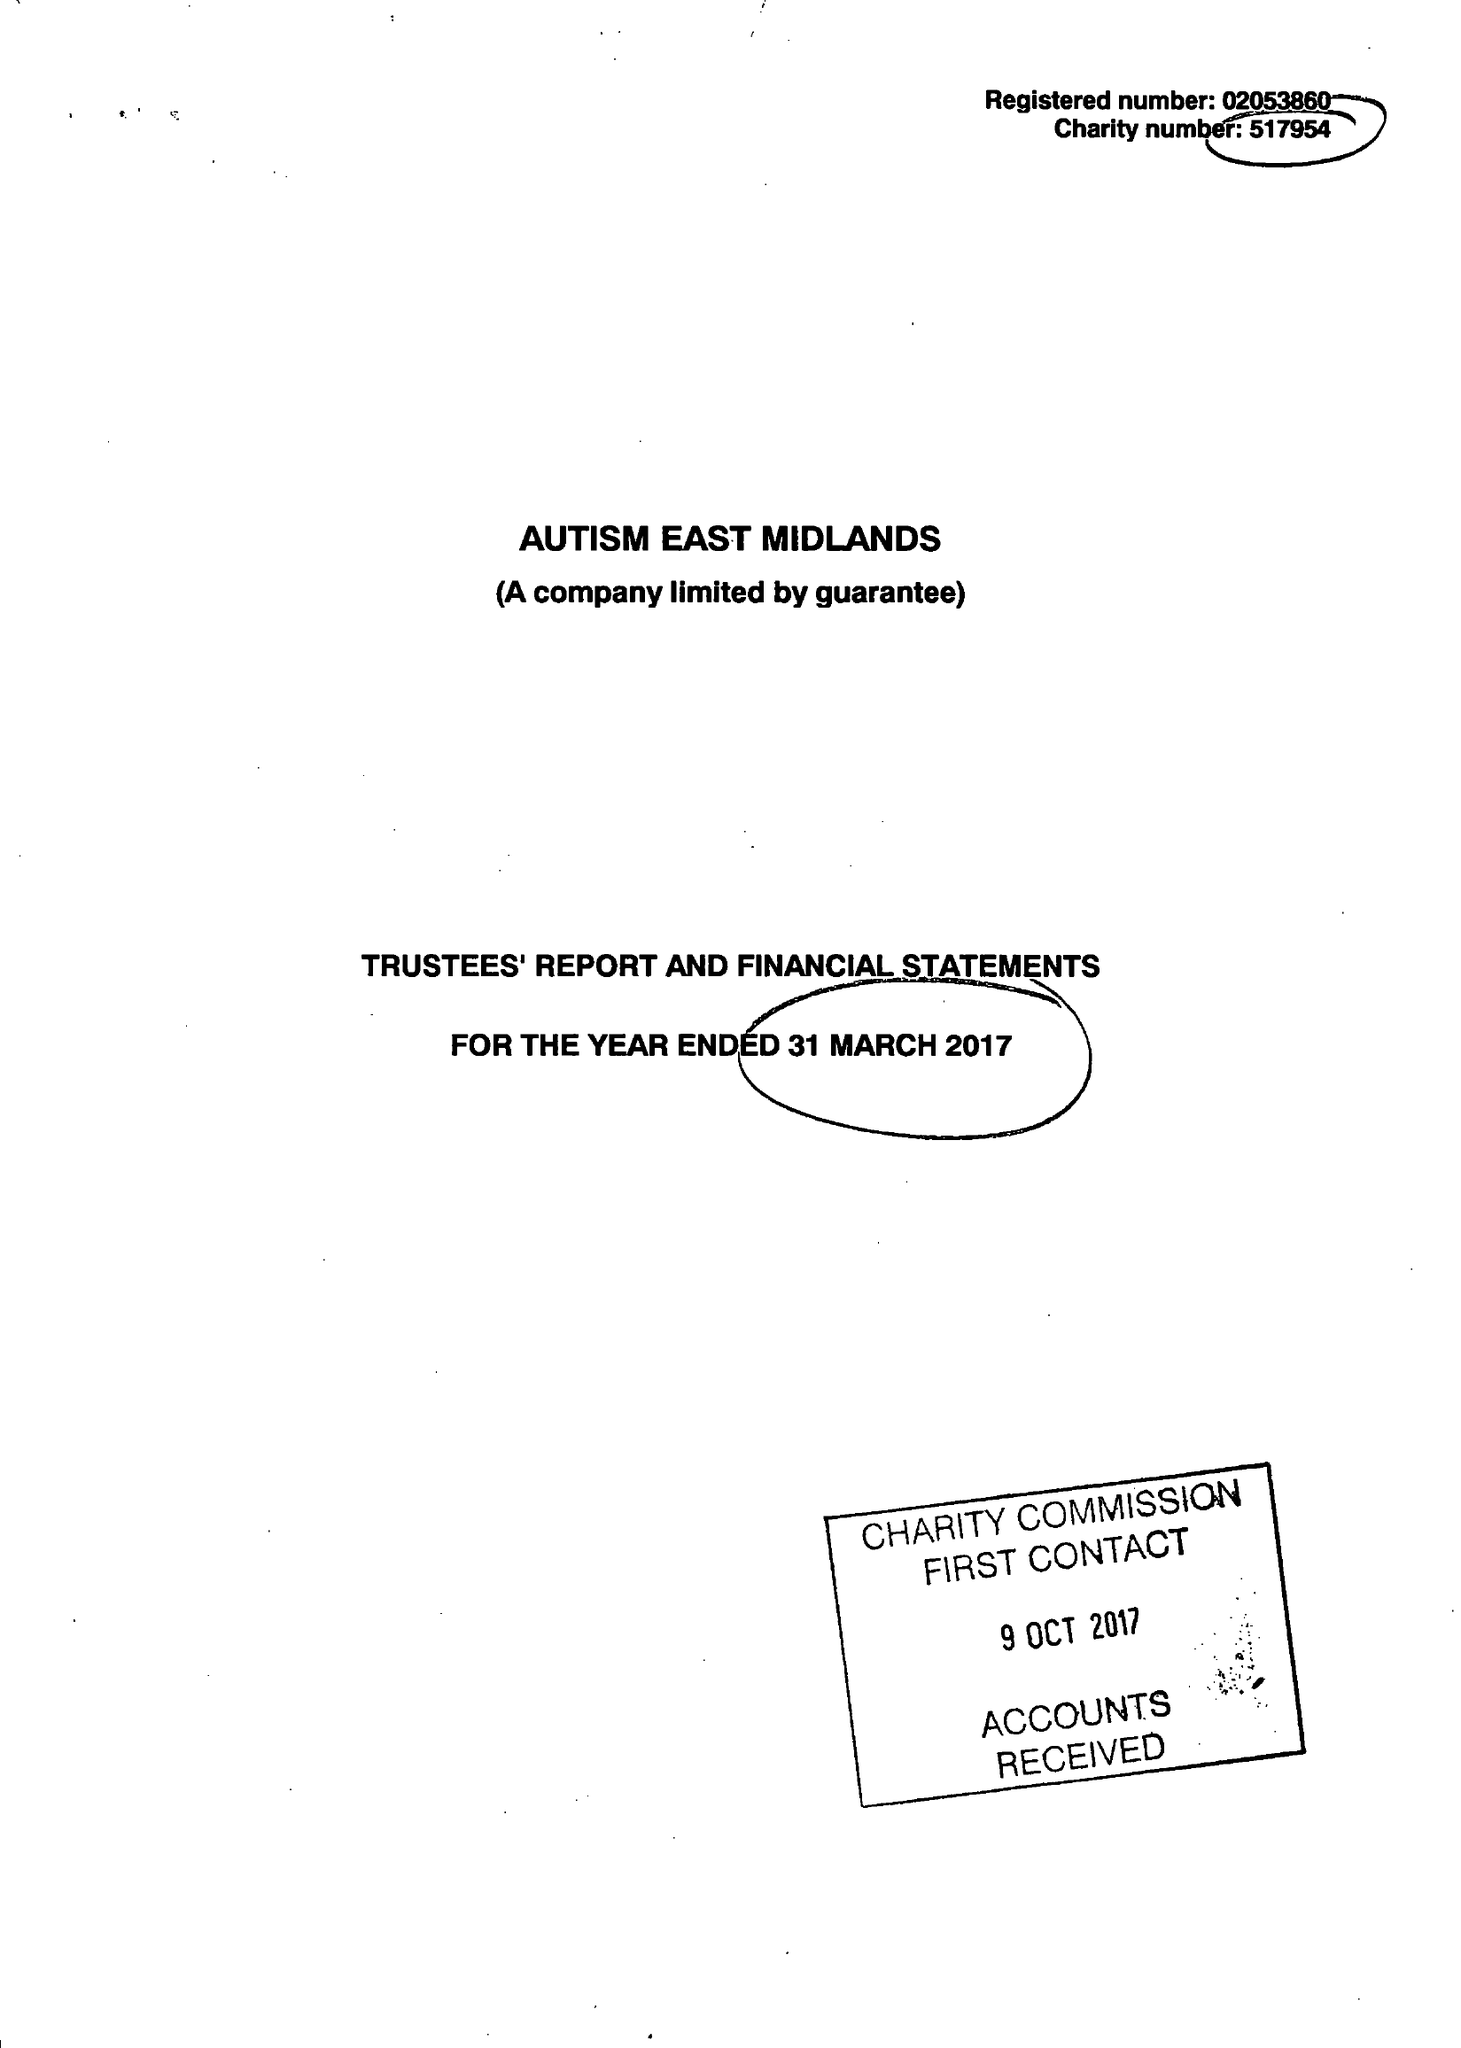What is the value for the report_date?
Answer the question using a single word or phrase. 2017-03-31 